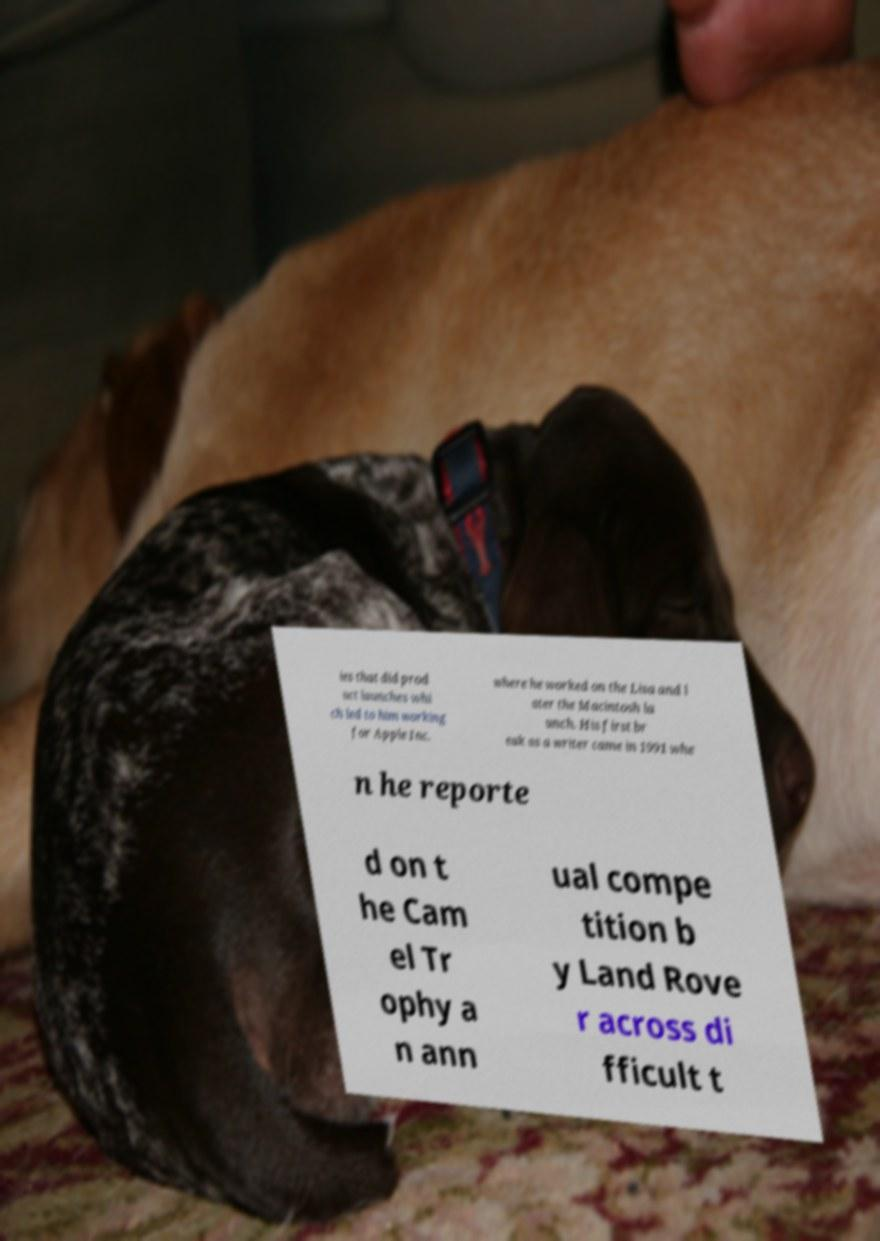Can you read and provide the text displayed in the image?This photo seems to have some interesting text. Can you extract and type it out for me? ies that did prod uct launches whi ch led to him working for Apple Inc. where he worked on the Lisa and l ater the Macintosh la unch. His first br eak as a writer came in 1991 whe n he reporte d on t he Cam el Tr ophy a n ann ual compe tition b y Land Rove r across di fficult t 